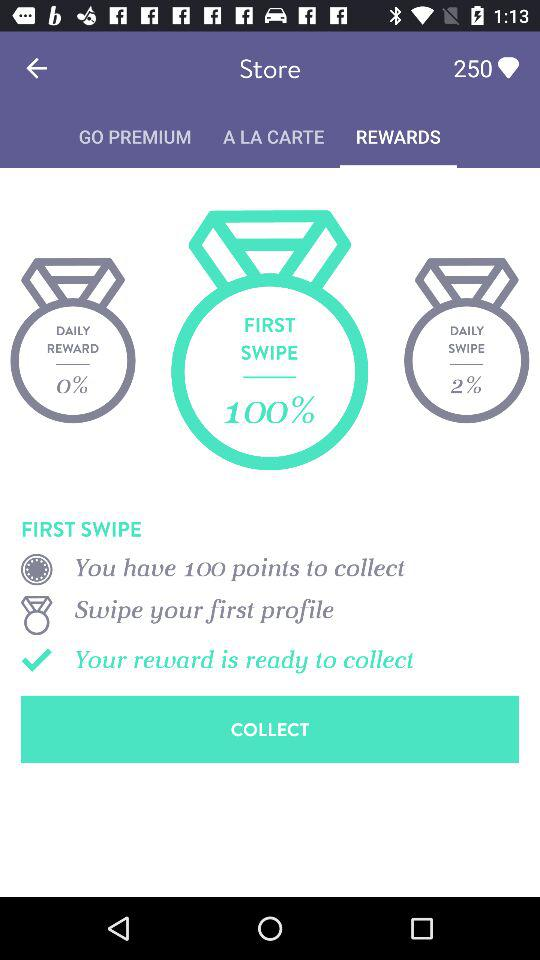What is the name of the user? The name of the user is Michele. 